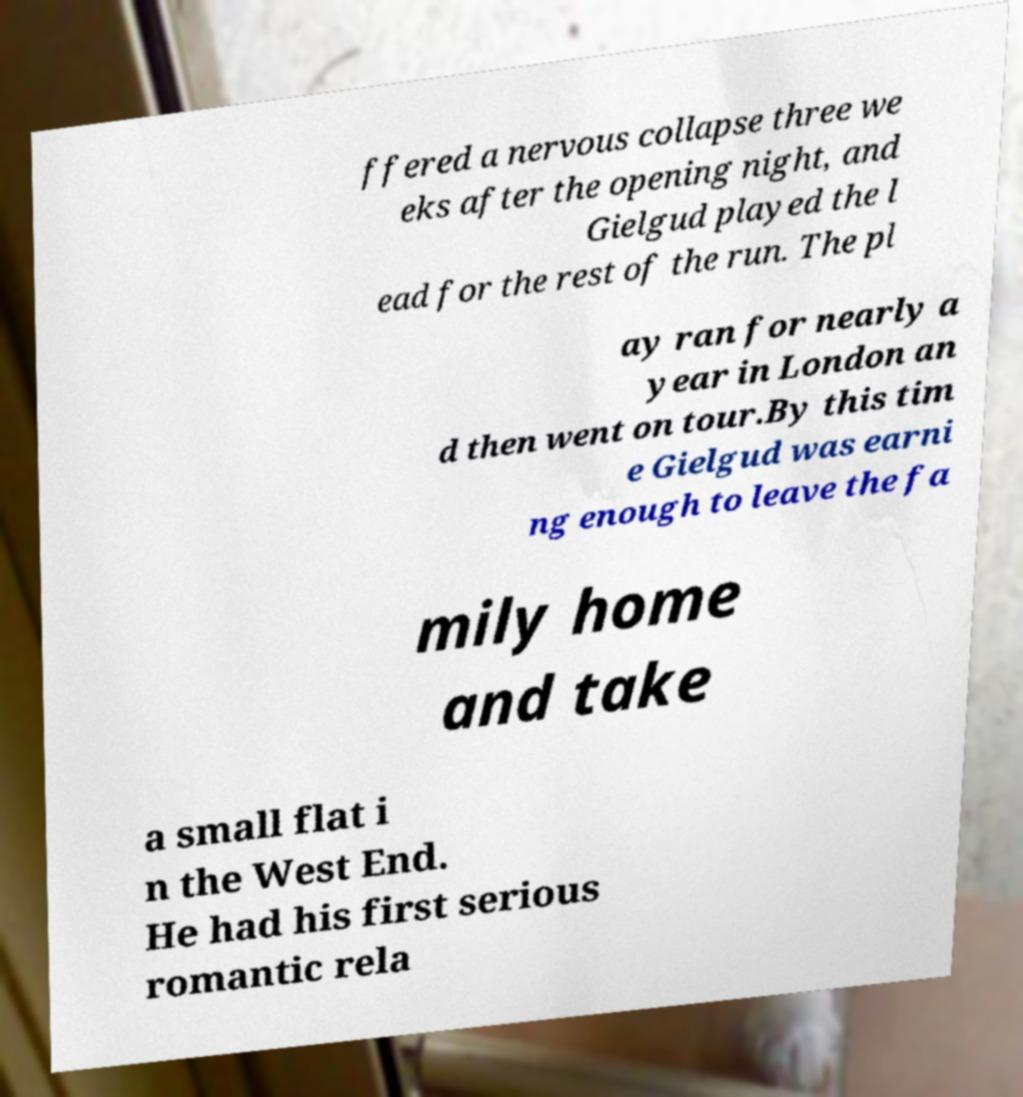There's text embedded in this image that I need extracted. Can you transcribe it verbatim? ffered a nervous collapse three we eks after the opening night, and Gielgud played the l ead for the rest of the run. The pl ay ran for nearly a year in London an d then went on tour.By this tim e Gielgud was earni ng enough to leave the fa mily home and take a small flat i n the West End. He had his first serious romantic rela 